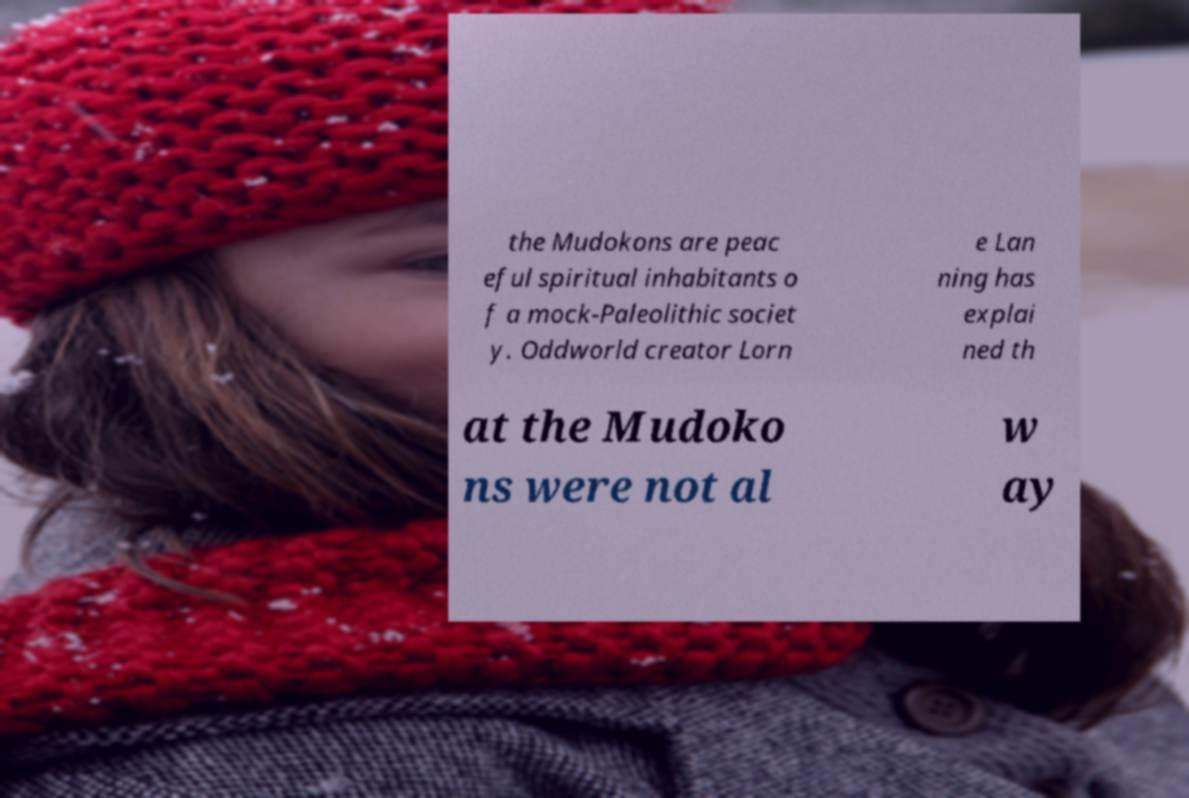Can you accurately transcribe the text from the provided image for me? the Mudokons are peac eful spiritual inhabitants o f a mock-Paleolithic societ y. Oddworld creator Lorn e Lan ning has explai ned th at the Mudoko ns were not al w ay 